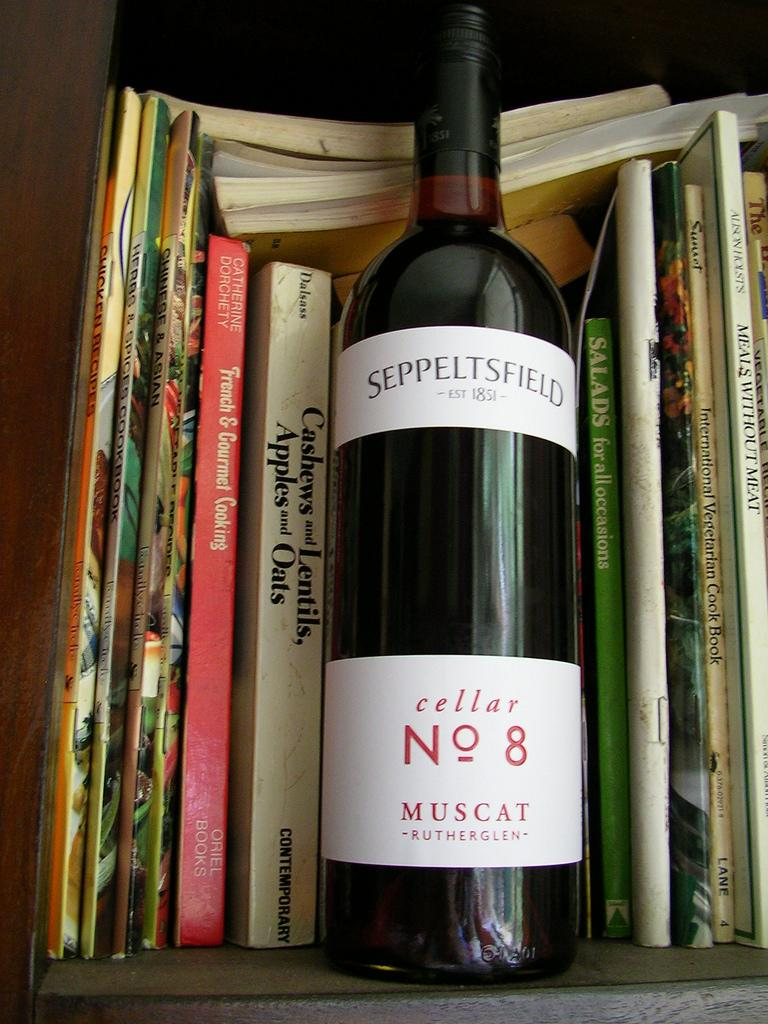<image>
Describe the image concisely. A bottle of Seppeltsfield Cellar No 8 sits with some books on a shelf. 